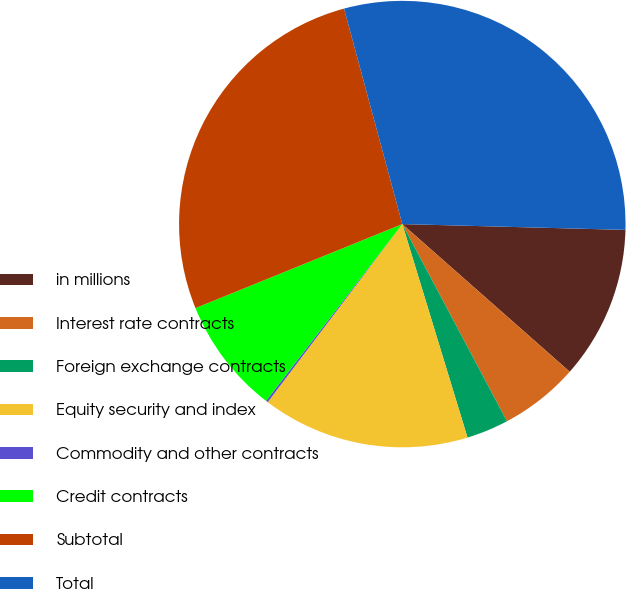Convert chart to OTSL. <chart><loc_0><loc_0><loc_500><loc_500><pie_chart><fcel>in millions<fcel>Interest rate contracts<fcel>Foreign exchange contracts<fcel>Equity security and index<fcel>Commodity and other contracts<fcel>Credit contracts<fcel>Subtotal<fcel>Total<nl><fcel>11.09%<fcel>5.73%<fcel>3.05%<fcel>15.02%<fcel>0.15%<fcel>8.41%<fcel>26.94%<fcel>29.62%<nl></chart> 